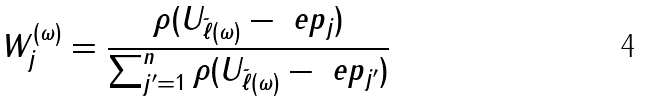<formula> <loc_0><loc_0><loc_500><loc_500>W _ { j } ^ { ( \omega ) } = \frac { \rho ( U _ { \tilde { \ell } ( \omega ) } - \ e p _ { j } ) } { \sum _ { j ^ { \prime } = 1 } ^ { n } \rho ( U _ { \tilde { \ell } ( \omega ) } - \ e p _ { j ^ { \prime } } ) }</formula> 